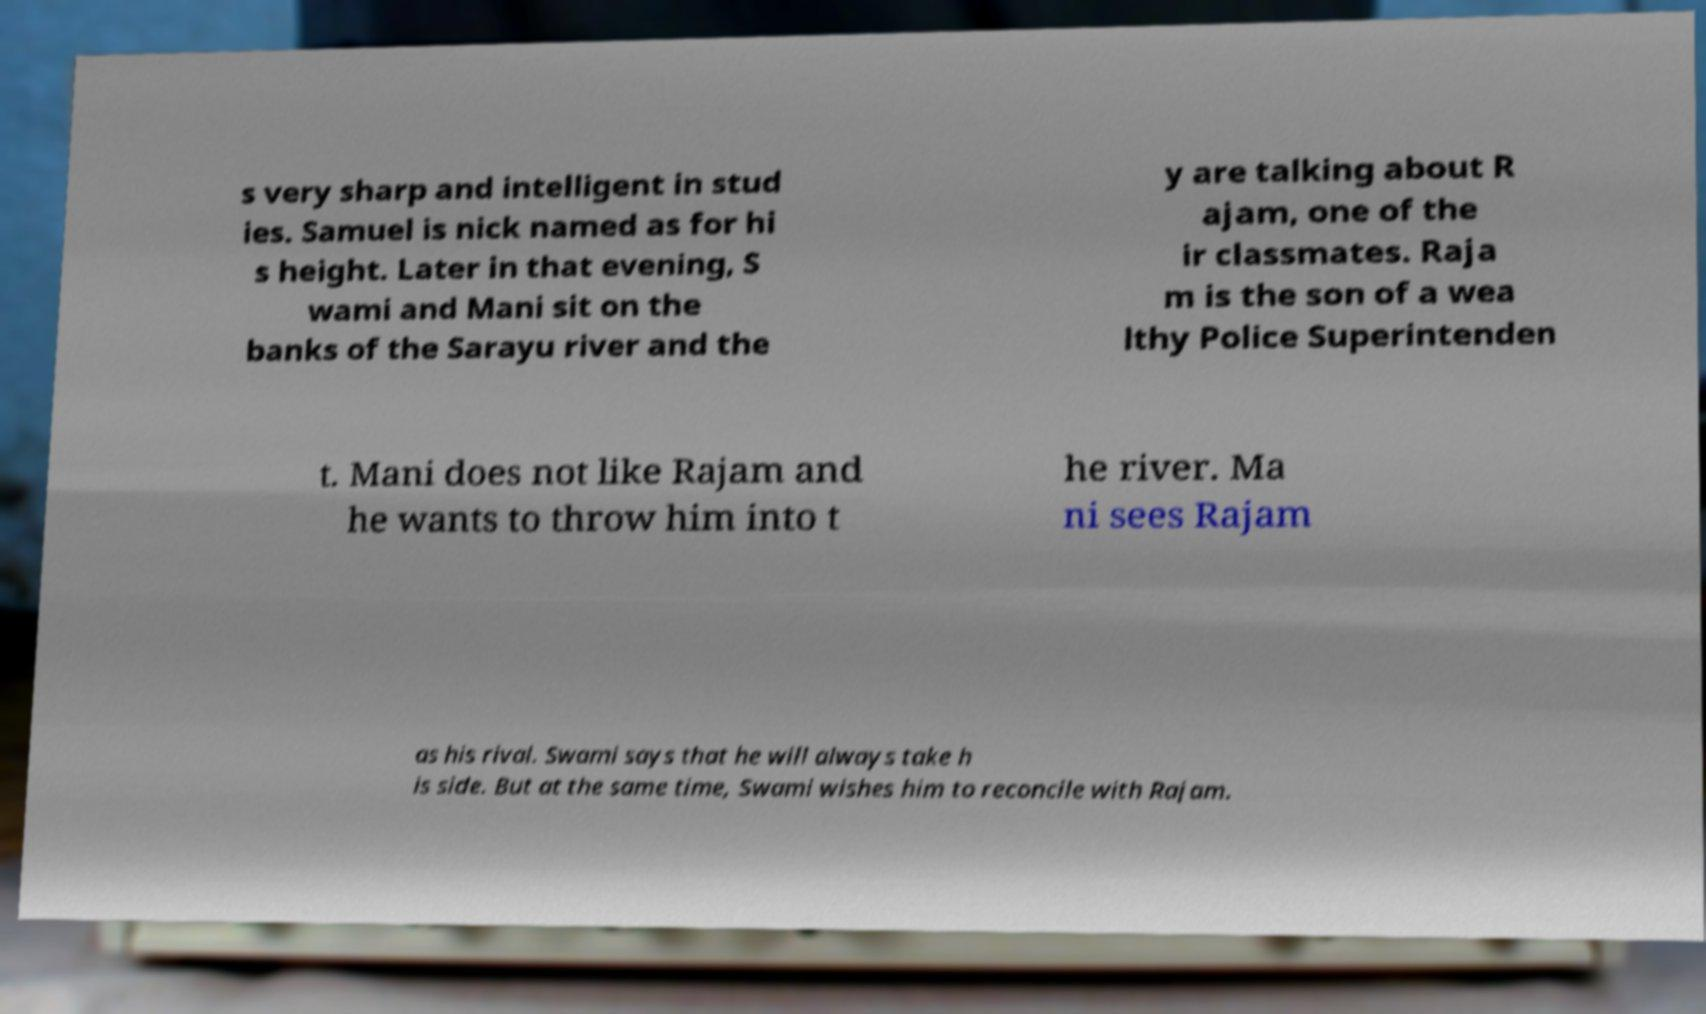What messages or text are displayed in this image? I need them in a readable, typed format. s very sharp and intelligent in stud ies. Samuel is nick named as for hi s height. Later in that evening, S wami and Mani sit on the banks of the Sarayu river and the y are talking about R ajam, one of the ir classmates. Raja m is the son of a wea lthy Police Superintenden t. Mani does not like Rajam and he wants to throw him into t he river. Ma ni sees Rajam as his rival. Swami says that he will always take h is side. But at the same time, Swami wishes him to reconcile with Rajam. 